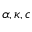<formula> <loc_0><loc_0><loc_500><loc_500>\alpha , \kappa , c</formula> 